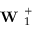Convert formula to latex. <formula><loc_0><loc_0><loc_500><loc_500>W _ { 1 } ^ { + }</formula> 